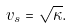<formula> <loc_0><loc_0><loc_500><loc_500>v _ { s } = \sqrt { \kappa } .</formula> 